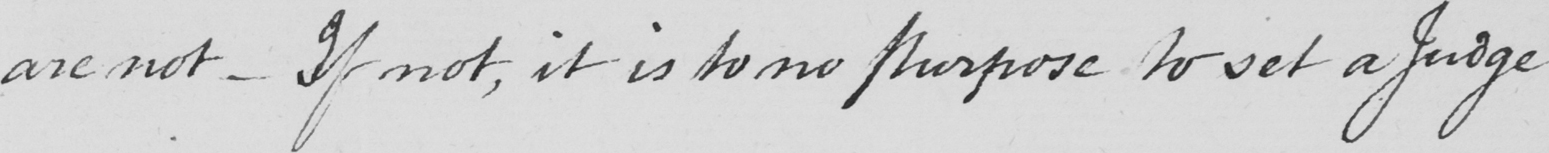What is written in this line of handwriting? are not  _  If not , it is to no purpose to set a Judge 